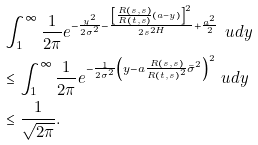<formula> <loc_0><loc_0><loc_500><loc_500>& \int _ { 1 } ^ { \infty } \frac { 1 } { 2 \pi } e ^ { - \frac { y ^ { 2 } } { 2 \sigma ^ { 2 } } - \frac { \left [ \frac { R ( s , s ) } { R ( t , s ) } ( a - y ) \right ] ^ { 2 } } { 2 s ^ { 2 H } } + \frac { a ^ { 2 } } { 2 } } \ u d y \\ & \leq \int _ { 1 } ^ { \infty } \frac { 1 } { 2 \pi } e ^ { - \frac { 1 } { 2 \sigma ^ { 2 } } \left ( y - a \frac { R ( s , s ) } { R ( t , s ) ^ { 2 } } \bar { \sigma } ^ { 2 } \right ) ^ { 2 } } \ u d y \\ & \leq \frac { 1 } { \sqrt { 2 \pi } } .</formula> 